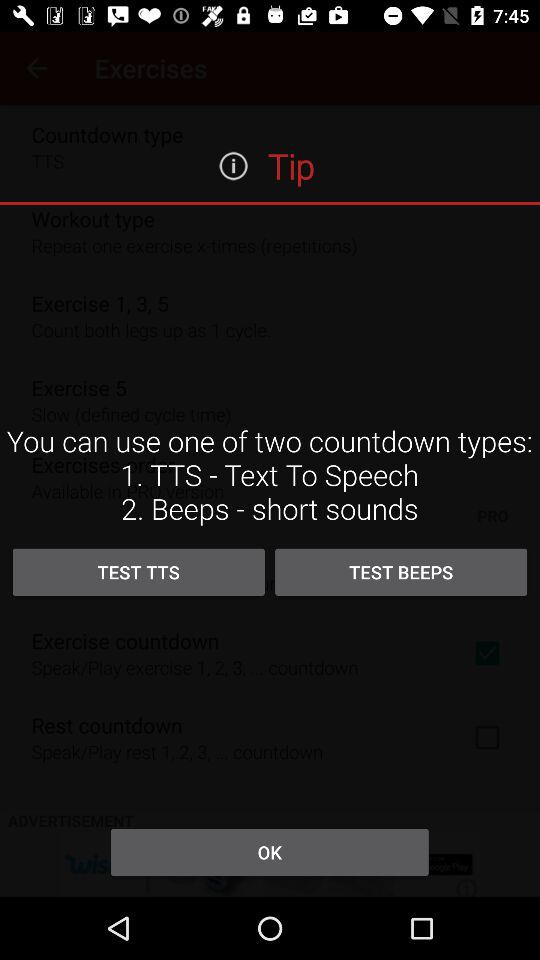How many types of countdown are available?
Answer the question using a single word or phrase. 2 